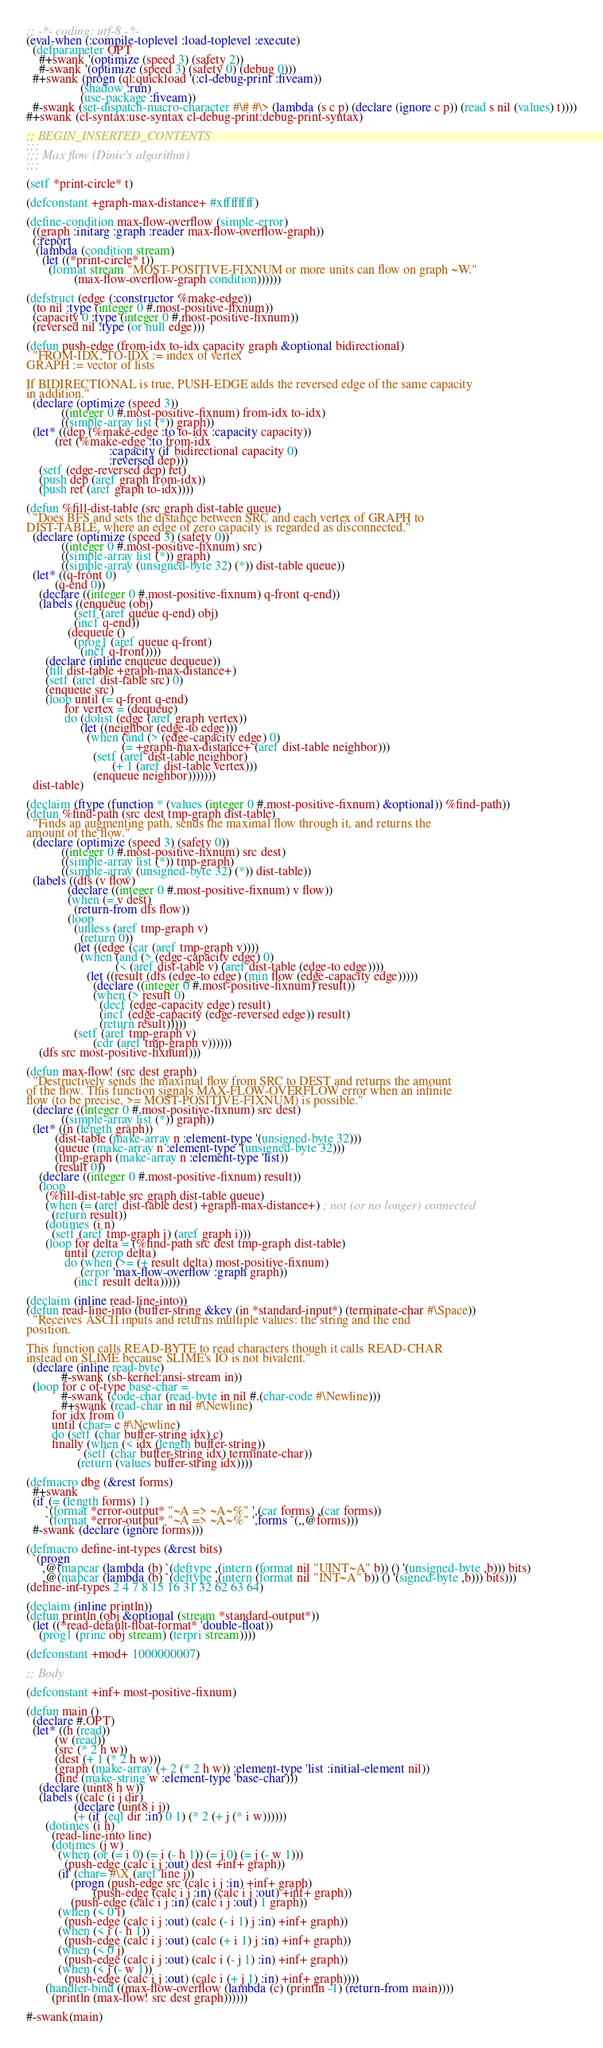Convert code to text. <code><loc_0><loc_0><loc_500><loc_500><_Lisp_>;; -*- coding: utf-8 -*-
(eval-when (:compile-toplevel :load-toplevel :execute)
  (defparameter OPT
    #+swank '(optimize (speed 3) (safety 2))
    #-swank '(optimize (speed 3) (safety 0) (debug 0)))
  #+swank (progn (ql:quickload '(:cl-debug-print :fiveam))
                 (shadow :run)
                 (use-package :fiveam))
  #-swank (set-dispatch-macro-character #\# #\> (lambda (s c p) (declare (ignore c p)) (read s nil (values) t))))
#+swank (cl-syntax:use-syntax cl-debug-print:debug-print-syntax)

;; BEGIN_INSERTED_CONTENTS
;;;
;;; Max flow (Dinic's algorithm)
;;;

(setf *print-circle* t)

(defconstant +graph-max-distance+ #xffffffff)

(define-condition max-flow-overflow (simple-error)
  ((graph :initarg :graph :reader max-flow-overflow-graph))
  (:report
   (lambda (condition stream)
     (let ((*print-circle* t))
       (format stream "MOST-POSITIVE-FIXNUM or more units can flow on graph ~W."
               (max-flow-overflow-graph condition))))))

(defstruct (edge (:constructor %make-edge))
  (to nil :type (integer 0 #.most-positive-fixnum))
  (capacity 0 :type (integer 0 #.most-positive-fixnum))
  (reversed nil :type (or null edge)))

(defun push-edge (from-idx to-idx capacity graph &optional bidirectional)
  "FROM-IDX, TO-IDX := index of vertex
GRAPH := vector of lists

If BIDIRECTIONAL is true, PUSH-EDGE adds the reversed edge of the same capacity
in addition."
  (declare (optimize (speed 3))
           ((integer 0 #.most-positive-fixnum) from-idx to-idx)
           ((simple-array list (*)) graph))
  (let* ((dep (%make-edge :to to-idx :capacity capacity))
         (ret (%make-edge :to from-idx
                          :capacity (if bidirectional capacity 0)
                          :reversed dep)))
    (setf (edge-reversed dep) ret)
    (push dep (aref graph from-idx))
    (push ret (aref graph to-idx))))

(defun %fill-dist-table (src graph dist-table queue)
  "Does BFS and sets the distance between SRC and each vertex of GRAPH to
DIST-TABLE, where an edge of zero capacity is regarded as disconnected."
  (declare (optimize (speed 3) (safety 0))
           ((integer 0 #.most-positive-fixnum) src)
           ((simple-array list (*)) graph)
           ((simple-array (unsigned-byte 32) (*)) dist-table queue))
  (let* ((q-front 0)
         (q-end 0))
    (declare ((integer 0 #.most-positive-fixnum) q-front q-end))
    (labels ((enqueue (obj)
               (setf (aref queue q-end) obj)
               (incf q-end))
             (dequeue ()
               (prog1 (aref queue q-front)
                 (incf q-front))))
      (declare (inline enqueue dequeue))
      (fill dist-table +graph-max-distance+)
      (setf (aref dist-table src) 0)
      (enqueue src)
      (loop until (= q-front q-end)
            for vertex = (dequeue)
            do (dolist (edge (aref graph vertex))
                 (let ((neighbor (edge-to edge)))
                   (when (and (> (edge-capacity edge) 0)
                              (= +graph-max-distance+ (aref dist-table neighbor)))
                     (setf (aref dist-table neighbor)
                           (+ 1 (aref dist-table vertex)))
                     (enqueue neighbor)))))))
  dist-table)

(declaim (ftype (function * (values (integer 0 #.most-positive-fixnum) &optional)) %find-path))
(defun %find-path (src dest tmp-graph dist-table)
  "Finds an augmenting path, sends the maximal flow through it, and returns the
amount of the flow."
  (declare (optimize (speed 3) (safety 0))
           ((integer 0 #.most-positive-fixnum) src dest)
           ((simple-array list (*)) tmp-graph)
           ((simple-array (unsigned-byte 32) (*)) dist-table))
  (labels ((dfs (v flow)
             (declare ((integer 0 #.most-positive-fixnum) v flow))
             (when (= v dest)
               (return-from dfs flow))
             (loop
               (unless (aref tmp-graph v)
                 (return 0))
               (let ((edge (car (aref tmp-graph v))))
                 (when (and (> (edge-capacity edge) 0)
                            (< (aref dist-table v) (aref dist-table (edge-to edge))))
                   (let ((result (dfs (edge-to edge) (min flow (edge-capacity edge)))))
                     (declare ((integer 0 #.most-positive-fixnum) result))
                     (when (> result 0)
                       (decf (edge-capacity edge) result)
                       (incf (edge-capacity (edge-reversed edge)) result)
                       (return result)))))
               (setf (aref tmp-graph v)
                     (cdr (aref tmp-graph v))))))
    (dfs src most-positive-fixnum)))

(defun max-flow! (src dest graph)
  "Destructively sends the maximal flow from SRC to DEST and returns the amount
of the flow. This function signals MAX-FLOW-OVERFLOW error when an infinite
flow (to be precise, >= MOST-POSITIVE-FIXNUM) is possible."
  (declare ((integer 0 #.most-positive-fixnum) src dest)
           ((simple-array list (*)) graph))
  (let* ((n (length graph))
         (dist-table (make-array n :element-type '(unsigned-byte 32)))
         (queue (make-array n :element-type '(unsigned-byte 32)))
         (tmp-graph (make-array n :element-type 'list))
         (result 0))
    (declare ((integer 0 #.most-positive-fixnum) result))
    (loop
      (%fill-dist-table src graph dist-table queue)
      (when (= (aref dist-table dest) +graph-max-distance+) ; not (or no longer) connected
        (return result))
      (dotimes (i n)
        (setf (aref tmp-graph i) (aref graph i)))
      (loop for delta = (%find-path src dest tmp-graph dist-table)
            until (zerop delta)
            do (when (>= (+ result delta) most-positive-fixnum)
                 (error 'max-flow-overflow :graph graph))
               (incf result delta)))))

(declaim (inline read-line-into))
(defun read-line-into (buffer-string &key (in *standard-input*) (terminate-char #\Space))
  "Receives ASCII inputs and returns multiple values: the string and the end
position.

This function calls READ-BYTE to read characters though it calls READ-CHAR
instead on SLIME because SLIME's IO is not bivalent."
  (declare (inline read-byte)
           #-swank (sb-kernel:ansi-stream in))
  (loop for c of-type base-char =
           #-swank (code-char (read-byte in nil #.(char-code #\Newline)))
           #+swank (read-char in nil #\Newline)
        for idx from 0
        until (char= c #\Newline)
        do (setf (char buffer-string idx) c)
        finally (when (< idx (length buffer-string))
                  (setf (char buffer-string idx) terminate-char))
                (return (values buffer-string idx))))

(defmacro dbg (&rest forms)
  #+swank
  (if (= (length forms) 1)
      `(format *error-output* "~A => ~A~%" ',(car forms) ,(car forms))
      `(format *error-output* "~A => ~A~%" ',forms `(,,@forms)))
  #-swank (declare (ignore forms)))

(defmacro define-int-types (&rest bits)
  `(progn
     ,@(mapcar (lambda (b) `(deftype ,(intern (format nil "UINT~A" b)) () '(unsigned-byte ,b))) bits)
     ,@(mapcar (lambda (b) `(deftype ,(intern (format nil "INT~A" b)) () '(signed-byte ,b))) bits)))
(define-int-types 2 4 7 8 15 16 31 32 62 63 64)

(declaim (inline println))
(defun println (obj &optional (stream *standard-output*))
  (let ((*read-default-float-format* 'double-float))
    (prog1 (princ obj stream) (terpri stream))))

(defconstant +mod+ 1000000007)

;; Body

(defconstant +inf+ most-positive-fixnum)

(defun main ()
  (declare #.OPT)
  (let* ((h (read))
         (w (read))
         (src (* 2 h w))
         (dest (+ 1 (* 2 h w)))
         (graph (make-array (+ 2 (* 2 h w)) :element-type 'list :initial-element nil))
         (line (make-string w :element-type 'base-char)))
    (declare (uint8 h w))
    (labels ((calc (i j dir)
               (declare (uint8 i j))
               (+ (if (eql dir :in) 0 1) (* 2 (+ j (* i w))))))
      (dotimes (i h)
        (read-line-into line)
        (dotimes (j w)
          (when (or (= i 0) (= i (- h 1)) (= j 0) (= j (- w 1)))
            (push-edge (calc i j :out) dest +inf+ graph))
          (if (char= #\X (aref line j))
              (progn (push-edge src (calc i j :in) +inf+ graph)
                     (push-edge (calc i j :in) (calc i j :out) +inf+ graph))
              (push-edge (calc i j :in) (calc i j :out) 1 graph))
          (when (< 0 i)
            (push-edge (calc i j :out) (calc (- i 1) j :in) +inf+ graph))
          (when (< i (- h 1))
            (push-edge (calc i j :out) (calc (+ i 1) j :in) +inf+ graph))
          (when (< 0 j)
            (push-edge (calc i j :out) (calc i (- j 1) :in) +inf+ graph))
          (when (< j (- w 1))
            (push-edge (calc i j :out) (calc i (+ j 1) :in) +inf+ graph))))
      (handler-bind ((max-flow-overflow (lambda (c) (println -1) (return-from main))))
        (println (max-flow! src dest graph))))))

#-swank(main)
</code> 